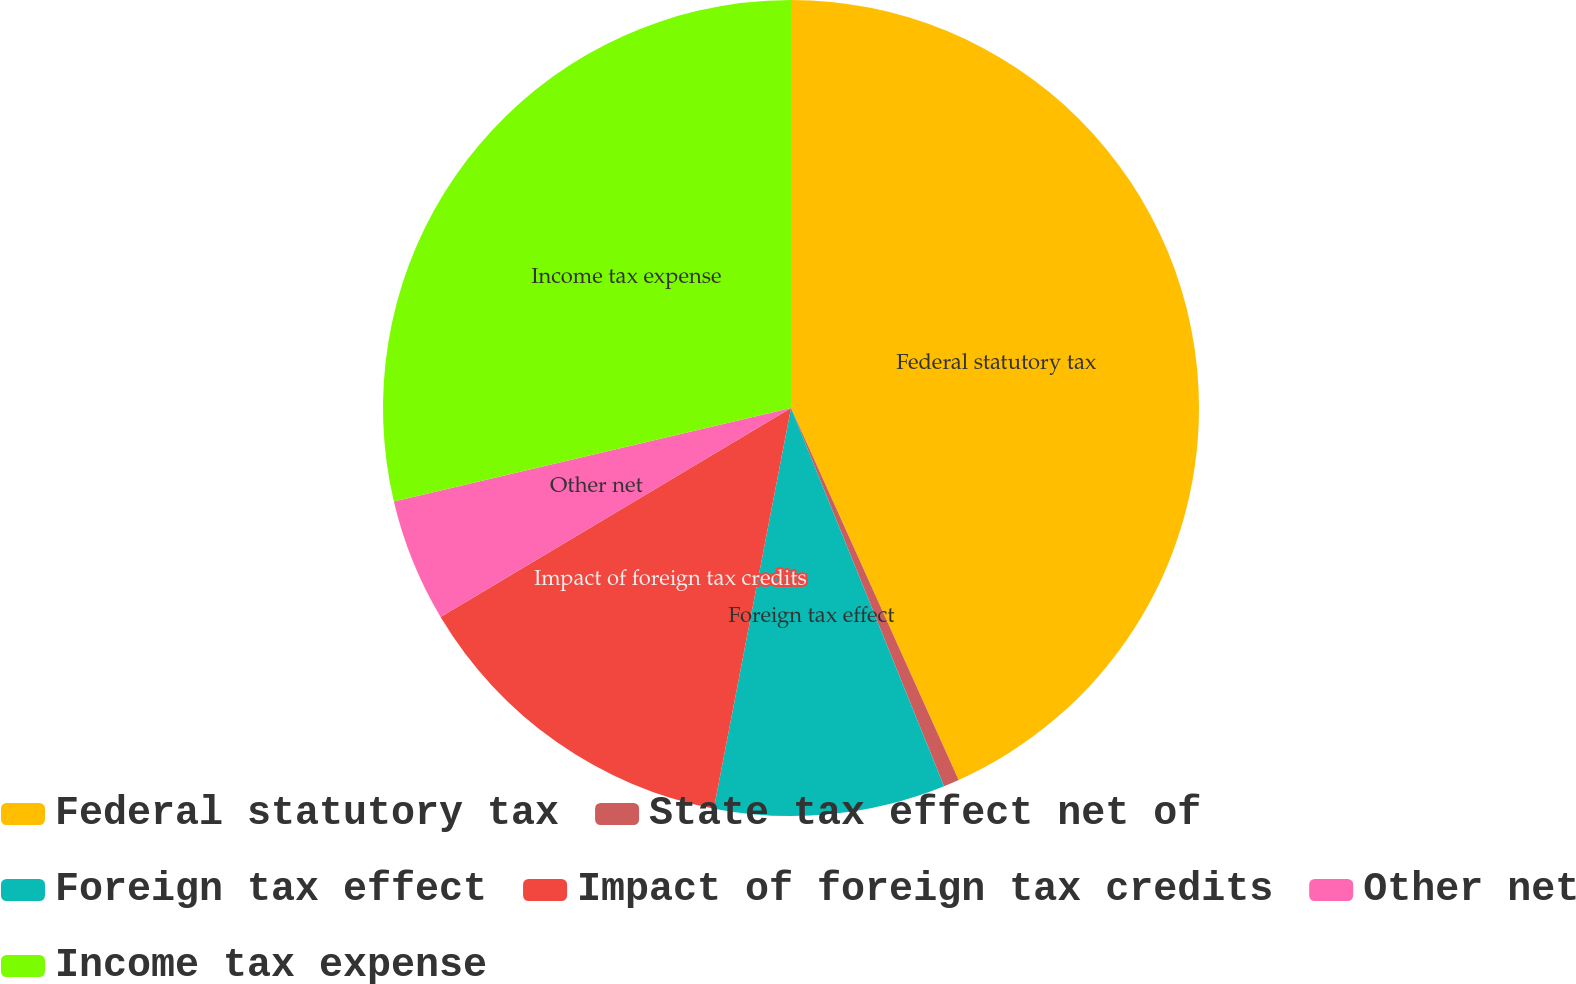<chart> <loc_0><loc_0><loc_500><loc_500><pie_chart><fcel>Federal statutory tax<fcel>State tax effect net of<fcel>Foreign tax effect<fcel>Impact of foreign tax credits<fcel>Other net<fcel>Income tax expense<nl><fcel>43.26%<fcel>0.62%<fcel>9.15%<fcel>13.41%<fcel>4.88%<fcel>28.68%<nl></chart> 